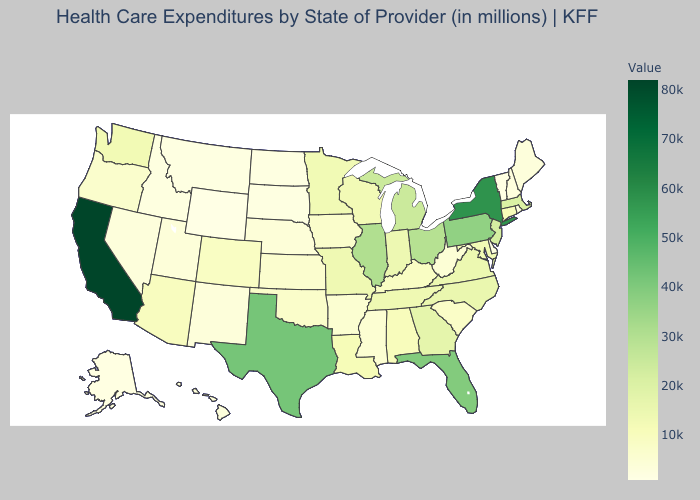Does New Jersey have the lowest value in the USA?
Concise answer only. No. Among the states that border North Dakota , which have the lowest value?
Keep it brief. South Dakota. Does Kansas have the lowest value in the MidWest?
Write a very short answer. No. 